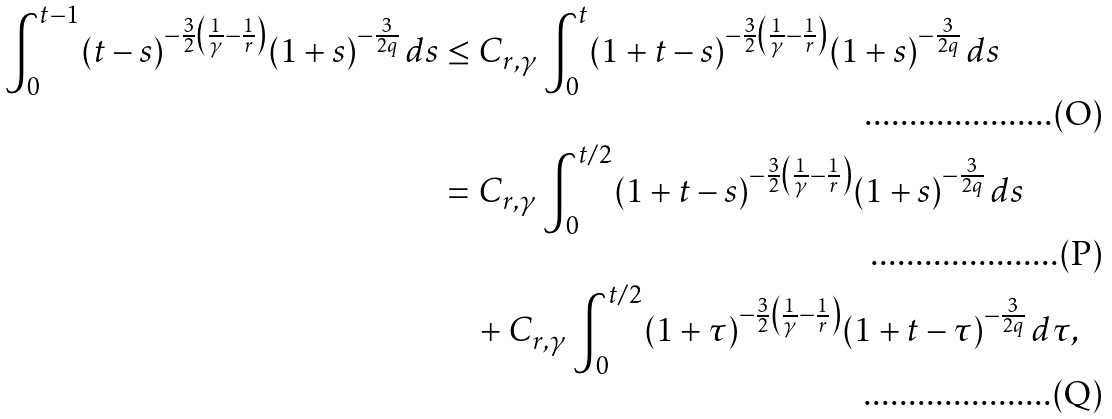<formula> <loc_0><loc_0><loc_500><loc_500>\int _ { 0 } ^ { t - 1 } ( t - s ) ^ { - \frac { 3 } { 2 } \left ( \frac { 1 } { \gamma } - \frac { 1 } { r } \right ) } ( 1 + s ) ^ { - \frac { 3 } { 2 q } } \, d s & \leq C _ { r , \gamma } \int _ { 0 } ^ { t } ( 1 + t - s ) ^ { - \frac { 3 } { 2 } \left ( \frac { 1 } { \gamma } - \frac { 1 } { r } \right ) } ( 1 + s ) ^ { - \frac { 3 } { 2 q } } \, d s \\ & = C _ { r , \gamma } \int _ { 0 } ^ { t / 2 } ( 1 + t - s ) ^ { - \frac { 3 } { 2 } \left ( \frac { 1 } { \gamma } - \frac { 1 } { r } \right ) } ( 1 + s ) ^ { - \frac { 3 } { 2 q } } \, d s \\ & \quad + C _ { r , \gamma } \int _ { 0 } ^ { t / 2 } ( 1 + \tau ) ^ { - \frac { 3 } { 2 } \left ( \frac { 1 } { \gamma } - \frac { 1 } { r } \right ) } ( 1 + t - \tau ) ^ { - \frac { 3 } { 2 q } } \, d \tau ,</formula> 